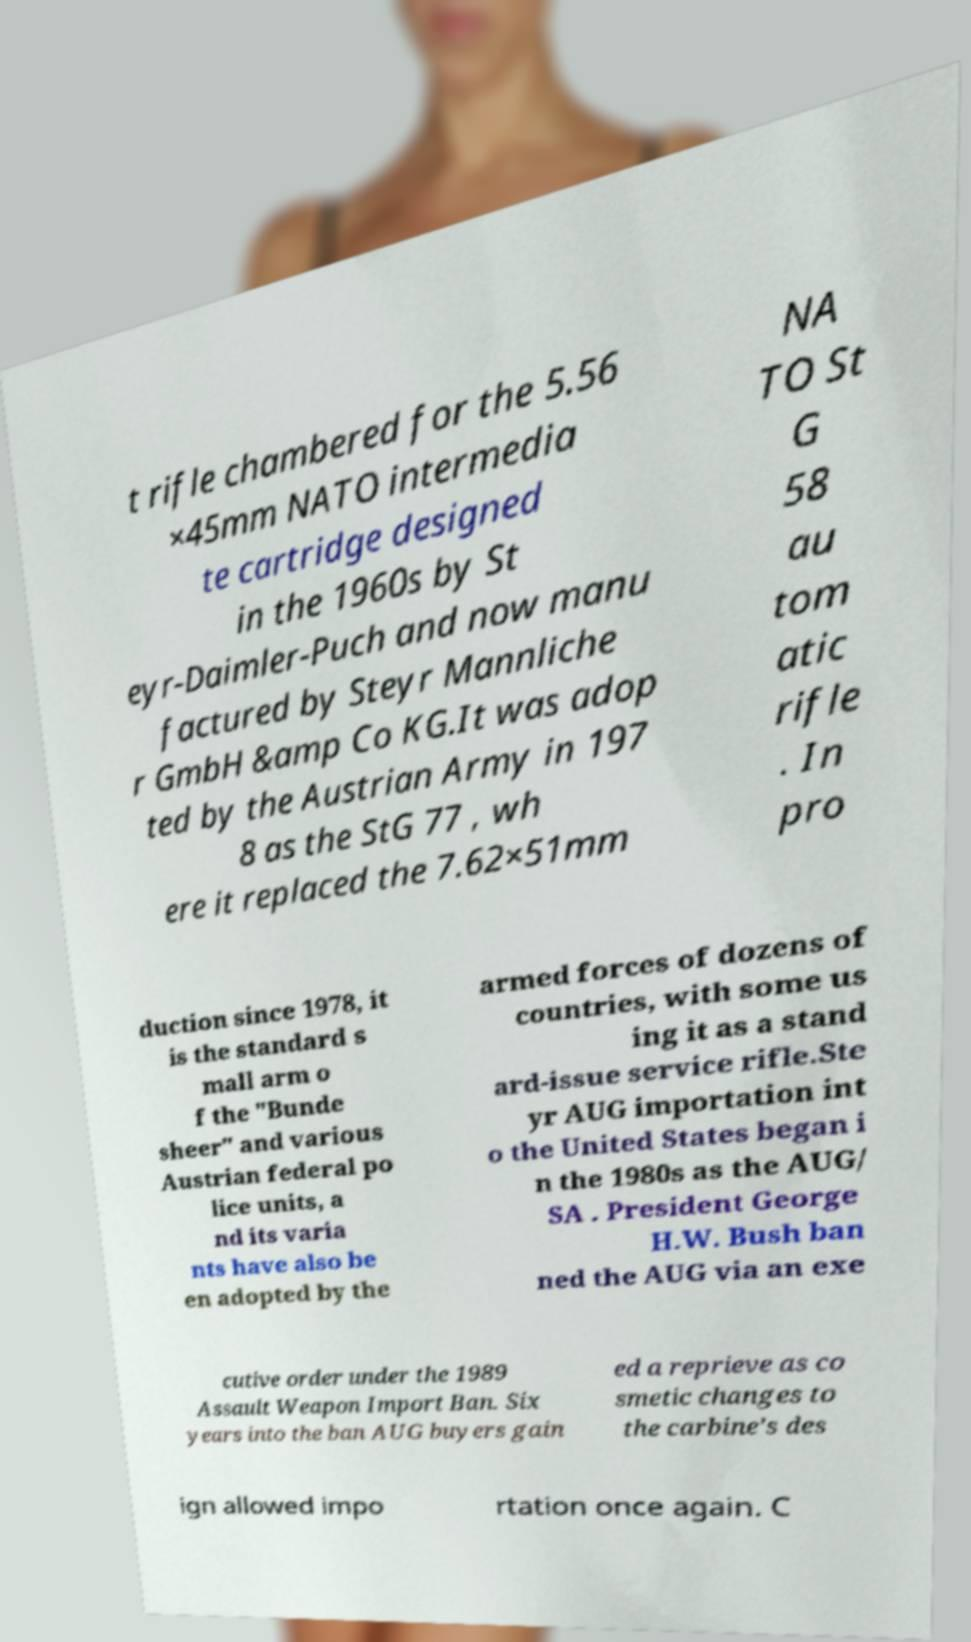What messages or text are displayed in this image? I need them in a readable, typed format. t rifle chambered for the 5.56 ×45mm NATO intermedia te cartridge designed in the 1960s by St eyr-Daimler-Puch and now manu factured by Steyr Mannliche r GmbH &amp Co KG.It was adop ted by the Austrian Army in 197 8 as the StG 77 , wh ere it replaced the 7.62×51mm NA TO St G 58 au tom atic rifle . In pro duction since 1978, it is the standard s mall arm o f the "Bunde sheer" and various Austrian federal po lice units, a nd its varia nts have also be en adopted by the armed forces of dozens of countries, with some us ing it as a stand ard-issue service rifle.Ste yr AUG importation int o the United States began i n the 1980s as the AUG/ SA . President George H.W. Bush ban ned the AUG via an exe cutive order under the 1989 Assault Weapon Import Ban. Six years into the ban AUG buyers gain ed a reprieve as co smetic changes to the carbine’s des ign allowed impo rtation once again. C 